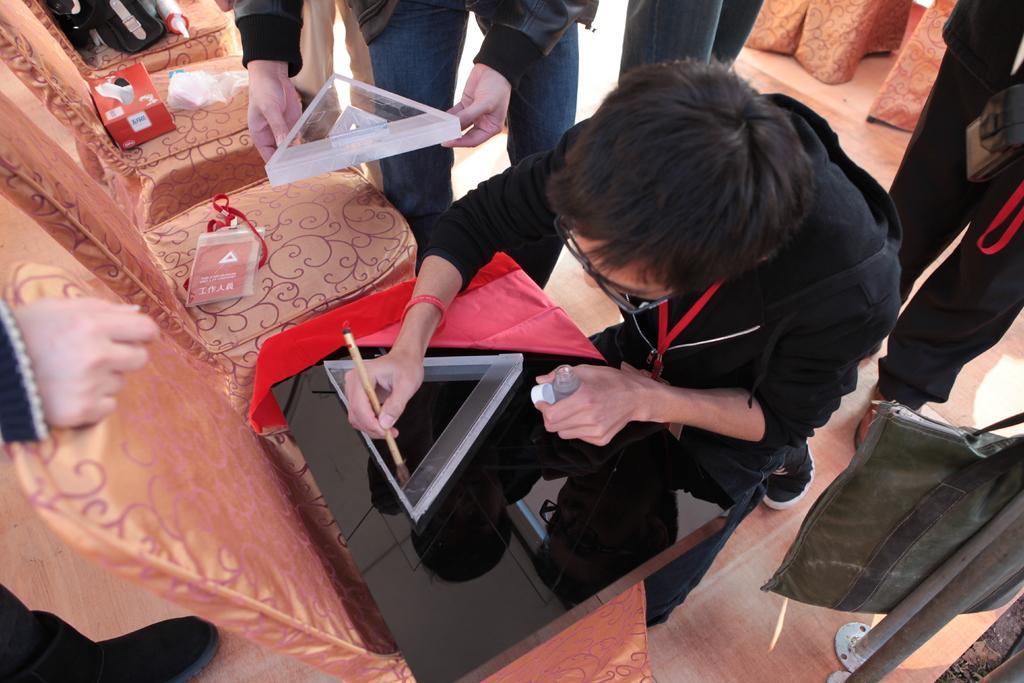How would you summarize this image in a sentence or two? In the picture I can see the chairs on the floor. There is a man on the right side is wearing a black color jacket and he is holding a wooden brush in his right hand. I can see a triangular glass structure on the black color block. There is another man at the top of the image, though his face is not visible and he is holding another triangular glass structure in his hands. I can see a bag on the bottom right side. I can see the hand of a person on the left side. 